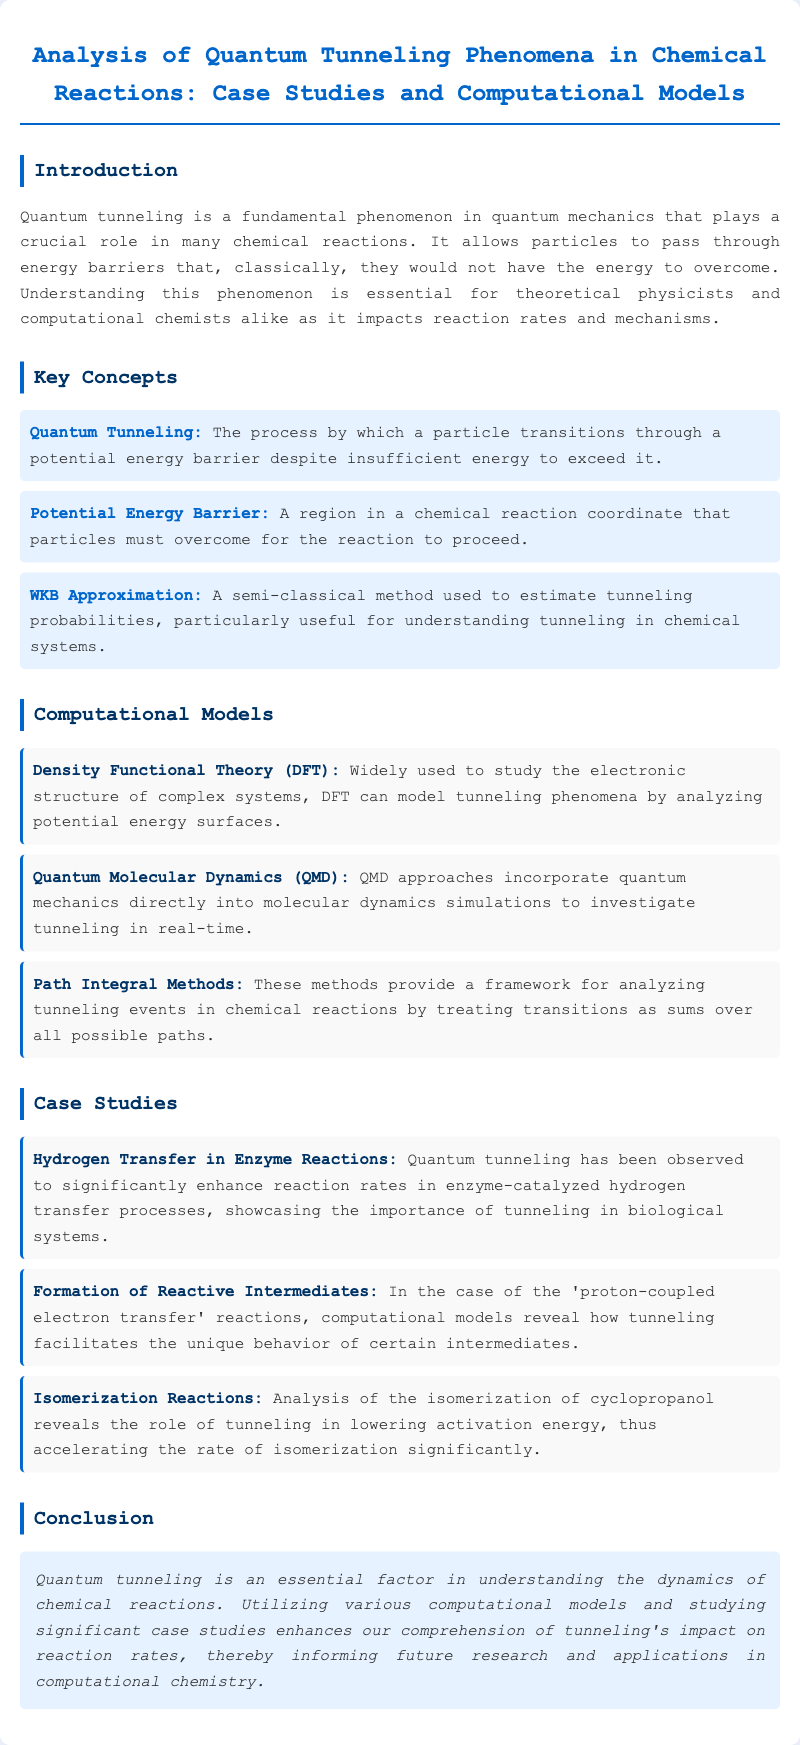what is quantum tunneling? Quantum tunneling is defined in the document as the process by which a particle transitions through a potential energy barrier despite insufficient energy to exceed it.
Answer: the process by which a particle transitions through a potential energy barrier despite insufficient energy to exceed it what is the WKB approximation? The WKB approximation is introduced as a semi-classical method used to estimate tunneling probabilities, particularly useful for understanding tunneling in chemical systems.
Answer: a semi-classical method used to estimate tunneling probabilities which computational model analyzes potential energy surfaces? The document states that Density Functional Theory (DFT) is widely used to study the electronic structure of complex systems and can model tunneling phenomena by analyzing potential energy surfaces.
Answer: Density Functional Theory (DFT) what case study involves enzyme reactions? The document mentions a case study on hydrogen transfer in enzyme reactions, where quantum tunneling enhances reaction rates.
Answer: Hydrogen Transfer in Enzyme Reactions how does tunneling affect activation energy in isomerization reactions? The text claims that tunneling lowers activation energy, thus accelerating the rate of isomerization significantly, particularly in the analysis of cyclopropanol.
Answer: lowers activation energy what key concept relates to obstacles particles must overcome? The document defines the potential energy barrier as a region in a chemical reaction coordinate that particles must overcome for the reaction to proceed.
Answer: Potential Energy Barrier what is one approach for real-time investigation of tunneling? Quantum Molecular Dynamics (QMD) is highlighted in the document as an approach that incorporates quantum mechanics directly into molecular dynamics simulations to investigate tunneling in real-time.
Answer: Quantum Molecular Dynamics (QMD) what does the conclusion emphasize about quantum tunneling? The conclusion states that quantum tunneling is an essential factor in understanding the dynamics of chemical reactions, impacting reaction rates significantly.
Answer: essential factor in understanding the dynamics of chemical reactions 